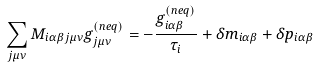Convert formula to latex. <formula><loc_0><loc_0><loc_500><loc_500>\sum _ { j \mu \nu } M _ { i \alpha \beta j \mu \nu } g _ { j \mu \nu } ^ { ( n e q ) } = - \frac { g _ { i \alpha \beta } ^ { ( n e q ) } } { \tau _ { i } } + \delta m _ { i \alpha \beta } + \delta p _ { i \alpha \beta }</formula> 